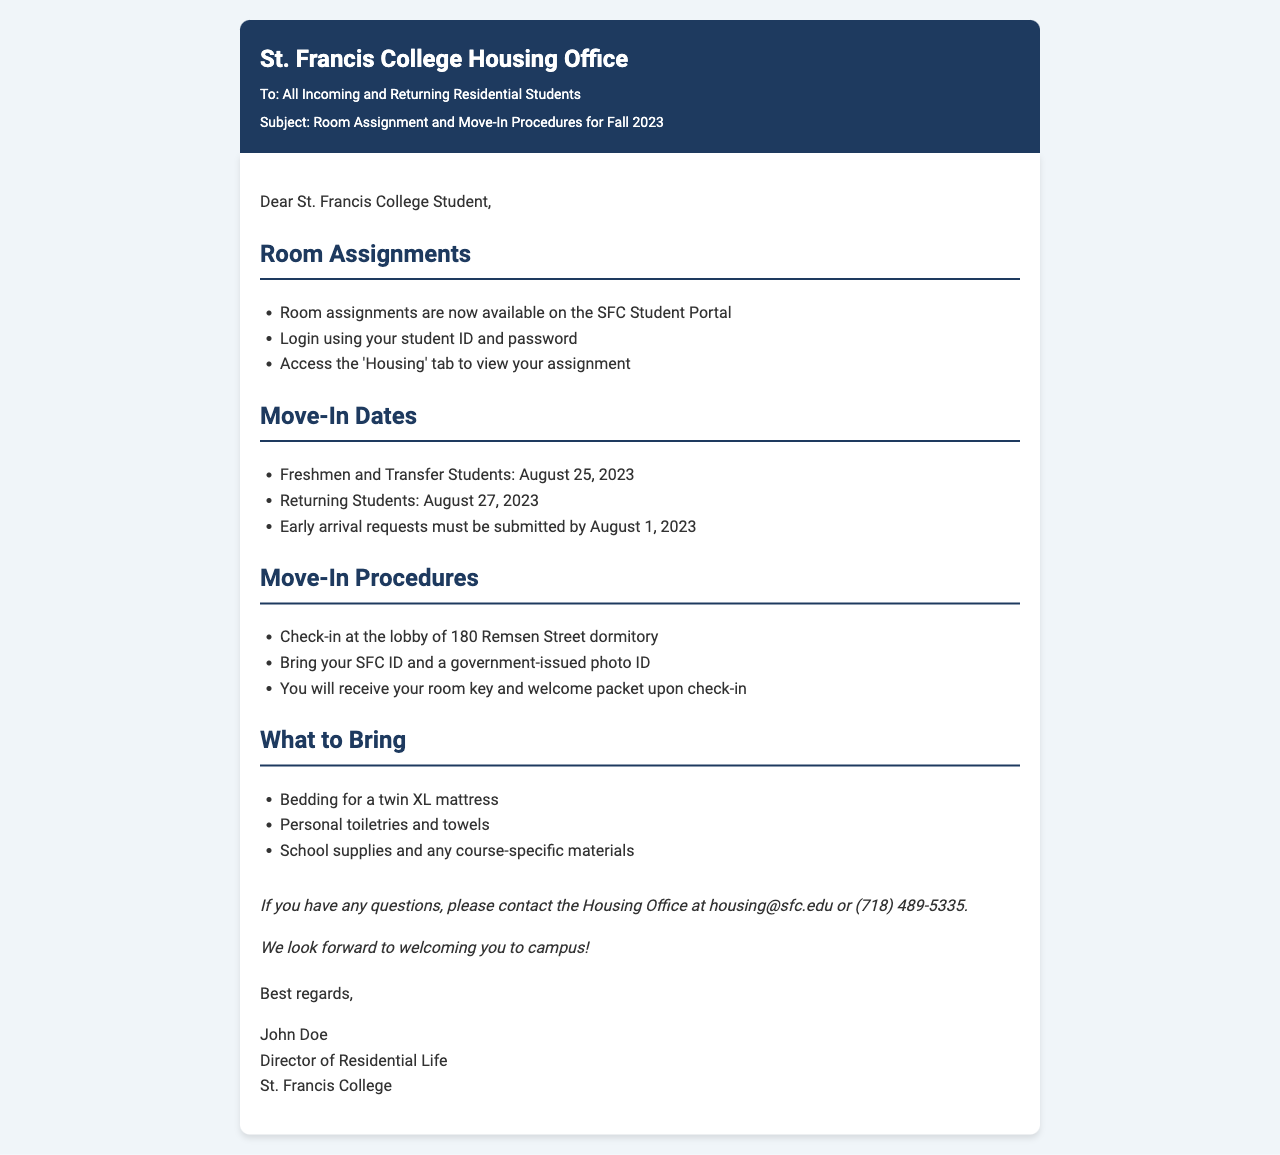What is the move-in date for freshmen? The document states that the move-in date for freshmen and transfer students is August 25, 2023.
Answer: August 25, 2023 What should you bring to check-in? The document specifies that you need to bring your SFC ID and a government-issued photo ID for check-in.
Answer: SFC ID and a government-issued photo ID When is the deadline for early arrival requests? According to the document, early arrival requests must be submitted by August 1, 2023.
Answer: August 1, 2023 Where do students check in on move-in day? The document mentions that check-in is at the lobby of the 180 Remsen Street dormitory.
Answer: 180 Remsen Street dormitory What must students do to view their room assignments? The document instructs students to log in using their student ID and password and access the 'Housing' tab.
Answer: Log in using student ID and password How many days are there between the move-in dates for freshmen and returning students? The difference between the two move-in dates is two days, with freshmen moving in on August 25 and returning students on August 27.
Answer: 2 days What type of mattress should students bring bedding for? The document specifies that students should bring bedding for a twin XL mattress.
Answer: Twin XL mattress Who is the Director of Residential Life? The document states that the Director of Residential Life is John Doe.
Answer: John Doe What is the contact email for the Housing Office? The document provides the email address for the Housing Office as housing@sfc.edu.
Answer: housing@sfc.edu 